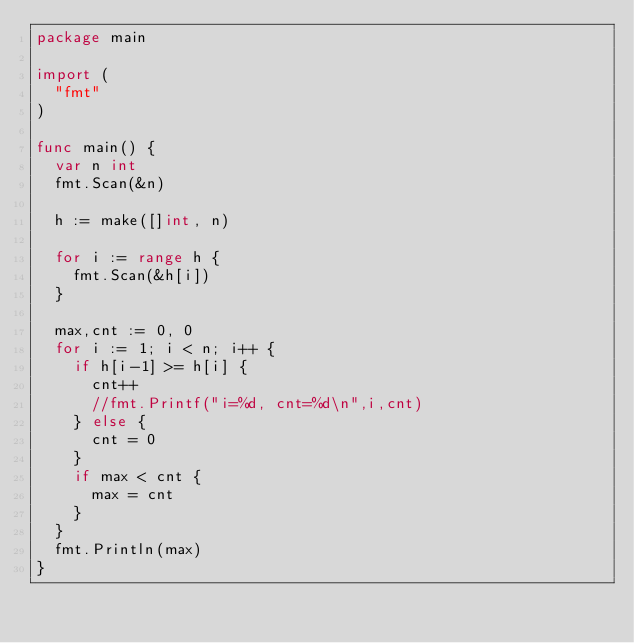<code> <loc_0><loc_0><loc_500><loc_500><_Go_>package main

import (
	"fmt"
)

func main() {
	var n int
	fmt.Scan(&n)
	
	h := make([]int, n)
	
	for i := range h {
		fmt.Scan(&h[i])
	}
	
	max,cnt := 0, 0
	for i := 1; i < n; i++ {
		if h[i-1] >= h[i] {
			cnt++
			//fmt.Printf("i=%d, cnt=%d\n",i,cnt)
		} else {
			cnt = 0
		}
		if max < cnt {
			max = cnt
		}
	}
	fmt.Println(max)
}</code> 